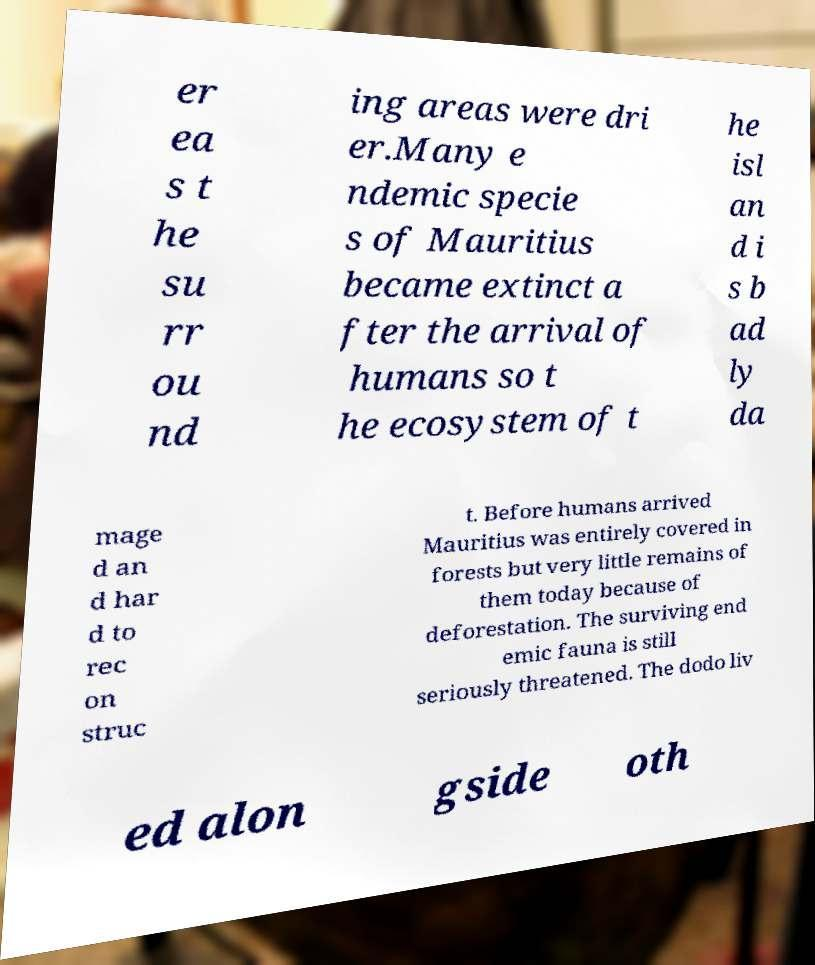Please identify and transcribe the text found in this image. er ea s t he su rr ou nd ing areas were dri er.Many e ndemic specie s of Mauritius became extinct a fter the arrival of humans so t he ecosystem of t he isl an d i s b ad ly da mage d an d har d to rec on struc t. Before humans arrived Mauritius was entirely covered in forests but very little remains of them today because of deforestation. The surviving end emic fauna is still seriously threatened. The dodo liv ed alon gside oth 